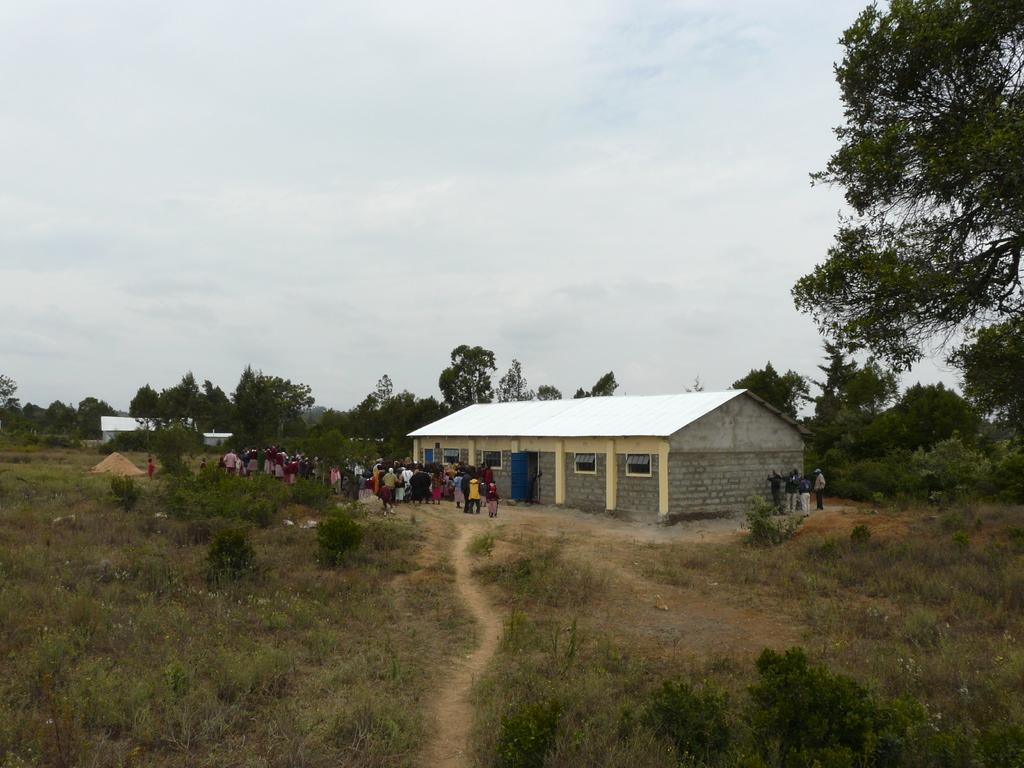Who or what can be seen in the image? There are people in the image. What type of natural elements are present in the image? There are plants, grass, and trees in the image. What type of structure is visible in the image? There is a house in the image. What part of the house can be seen in the image? There are windows in the image. What is visible in the background of the image? The sky is visible in the image. Can you see a receipt being blown by the air in the image? There is no receipt or air visible in the image. 